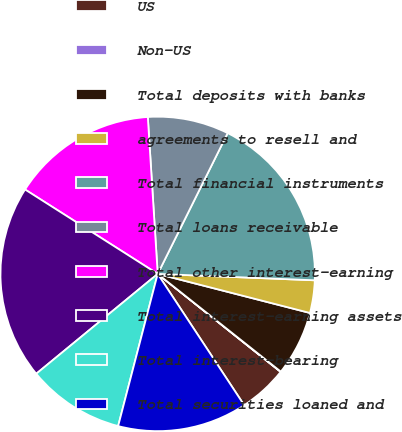Convert chart. <chart><loc_0><loc_0><loc_500><loc_500><pie_chart><fcel>US<fcel>Non-US<fcel>Total deposits with banks<fcel>agreements to resell and<fcel>Total financial instruments<fcel>Total loans receivable<fcel>Total other interest-earning<fcel>Total interest-earning assets<fcel>Total interest-bearing<fcel>Total securities loaned and<nl><fcel>5.02%<fcel>0.03%<fcel>6.68%<fcel>3.35%<fcel>18.31%<fcel>8.34%<fcel>14.98%<fcel>19.97%<fcel>10.0%<fcel>13.32%<nl></chart> 